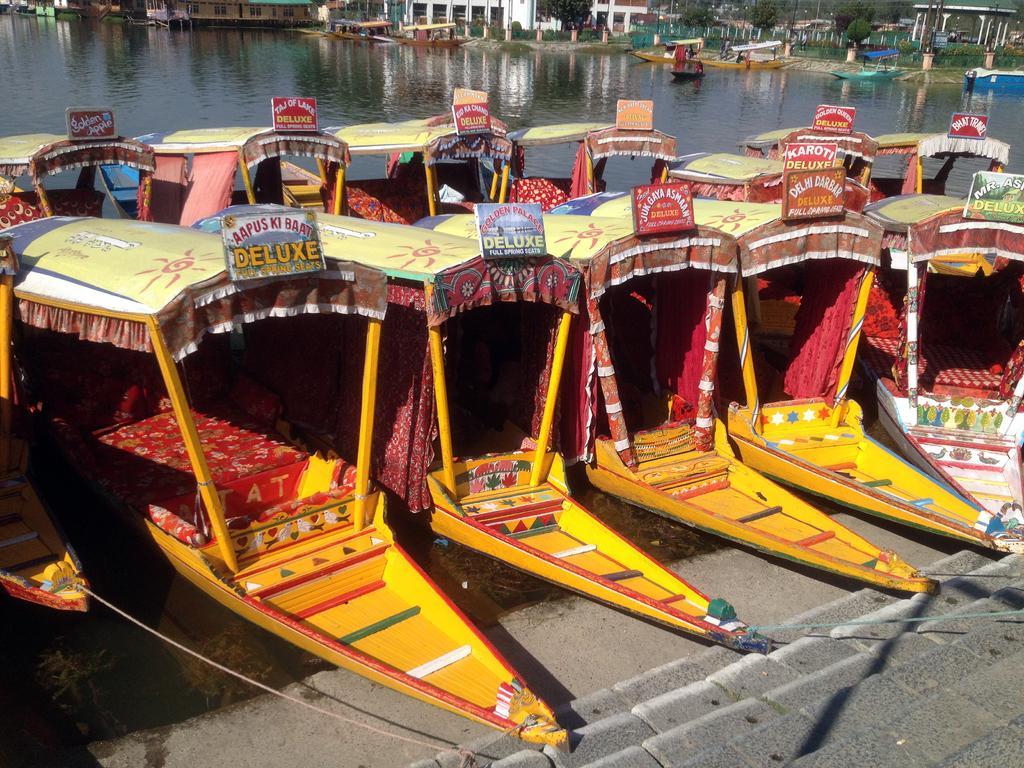Could you give a brief overview of what you see in this image? In the foreground of the image we can see a staircase. In the center of the image we can see group of boats in water with boards and text on them. In the background, we can see a group of buildings and trees. 